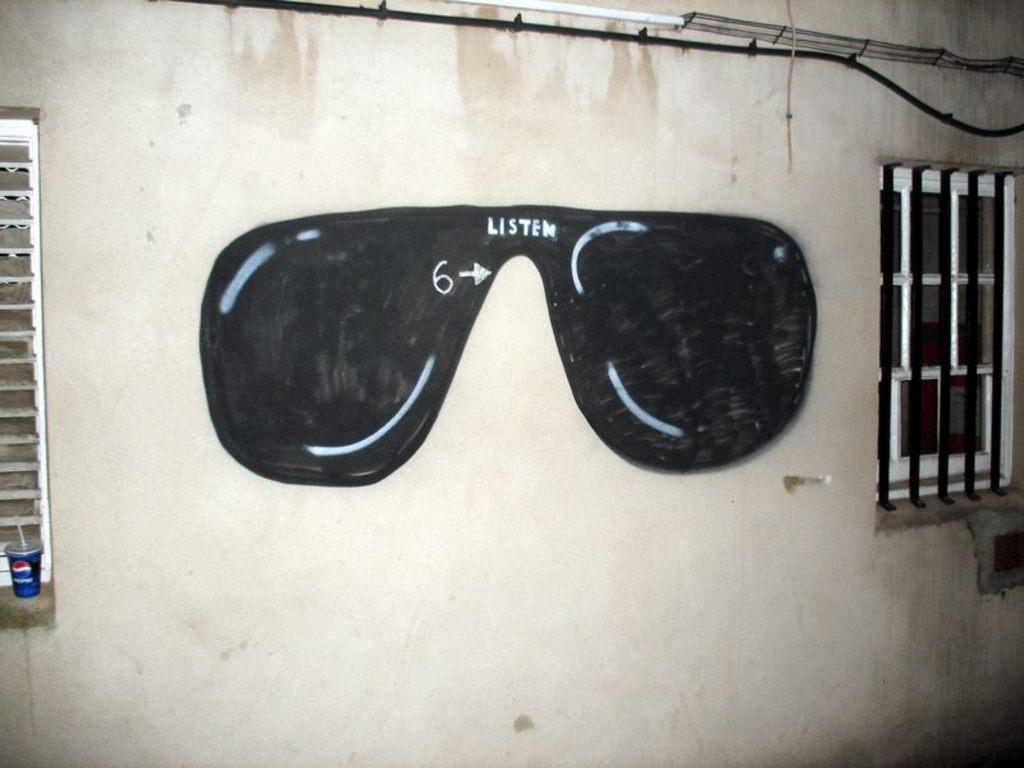What is present on the wall in the image? There are shades on the wall in the image. Can you describe the windows on the wall? There are windows on both the left and right sides of the wall. How many oranges are hanging from the baseball bat in the image? There is no baseball bat or oranges present in the image. 